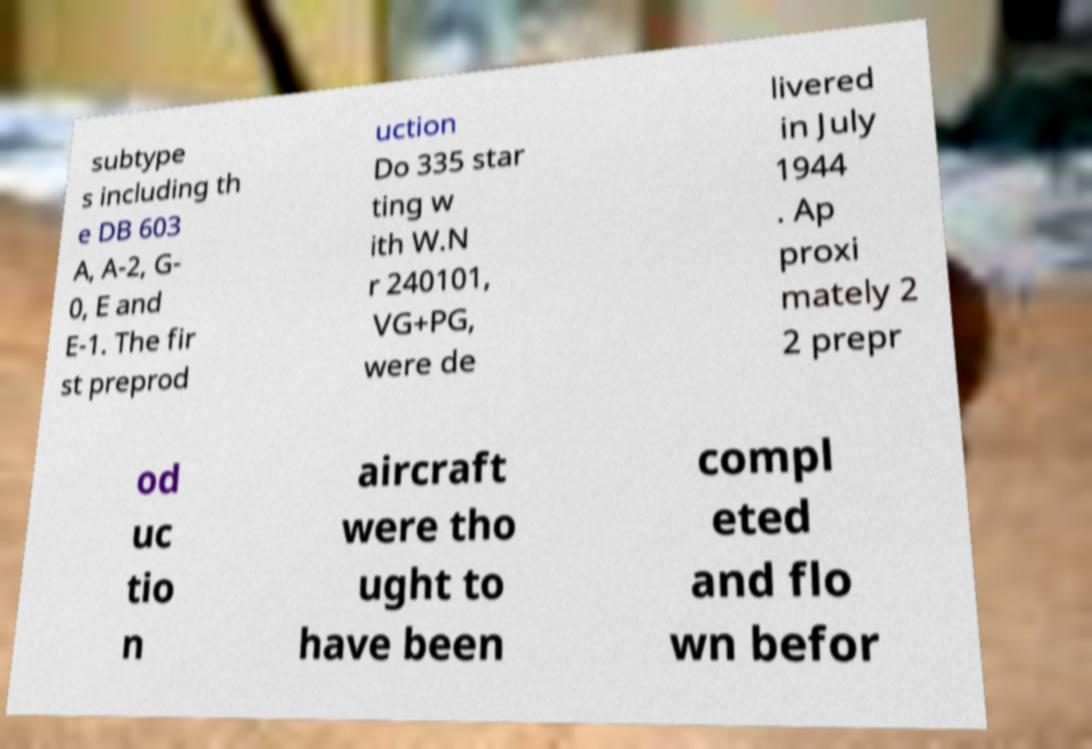Could you assist in decoding the text presented in this image and type it out clearly? subtype s including th e DB 603 A, A-2, G- 0, E and E-1. The fir st preprod uction Do 335 star ting w ith W.N r 240101, VG+PG, were de livered in July 1944 . Ap proxi mately 2 2 prepr od uc tio n aircraft were tho ught to have been compl eted and flo wn befor 